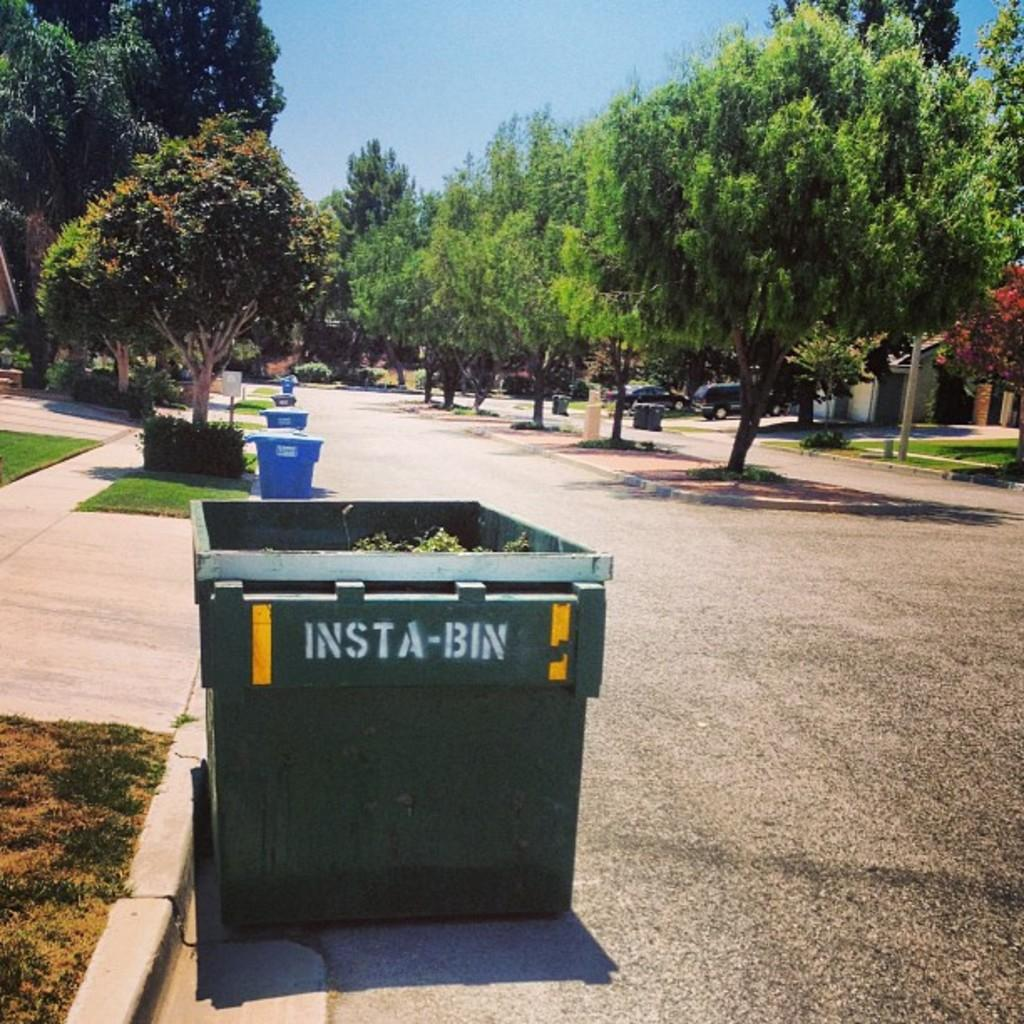<image>
Offer a succinct explanation of the picture presented. A tree-lined residential street is line with trash cans and an Insta-Bin. 